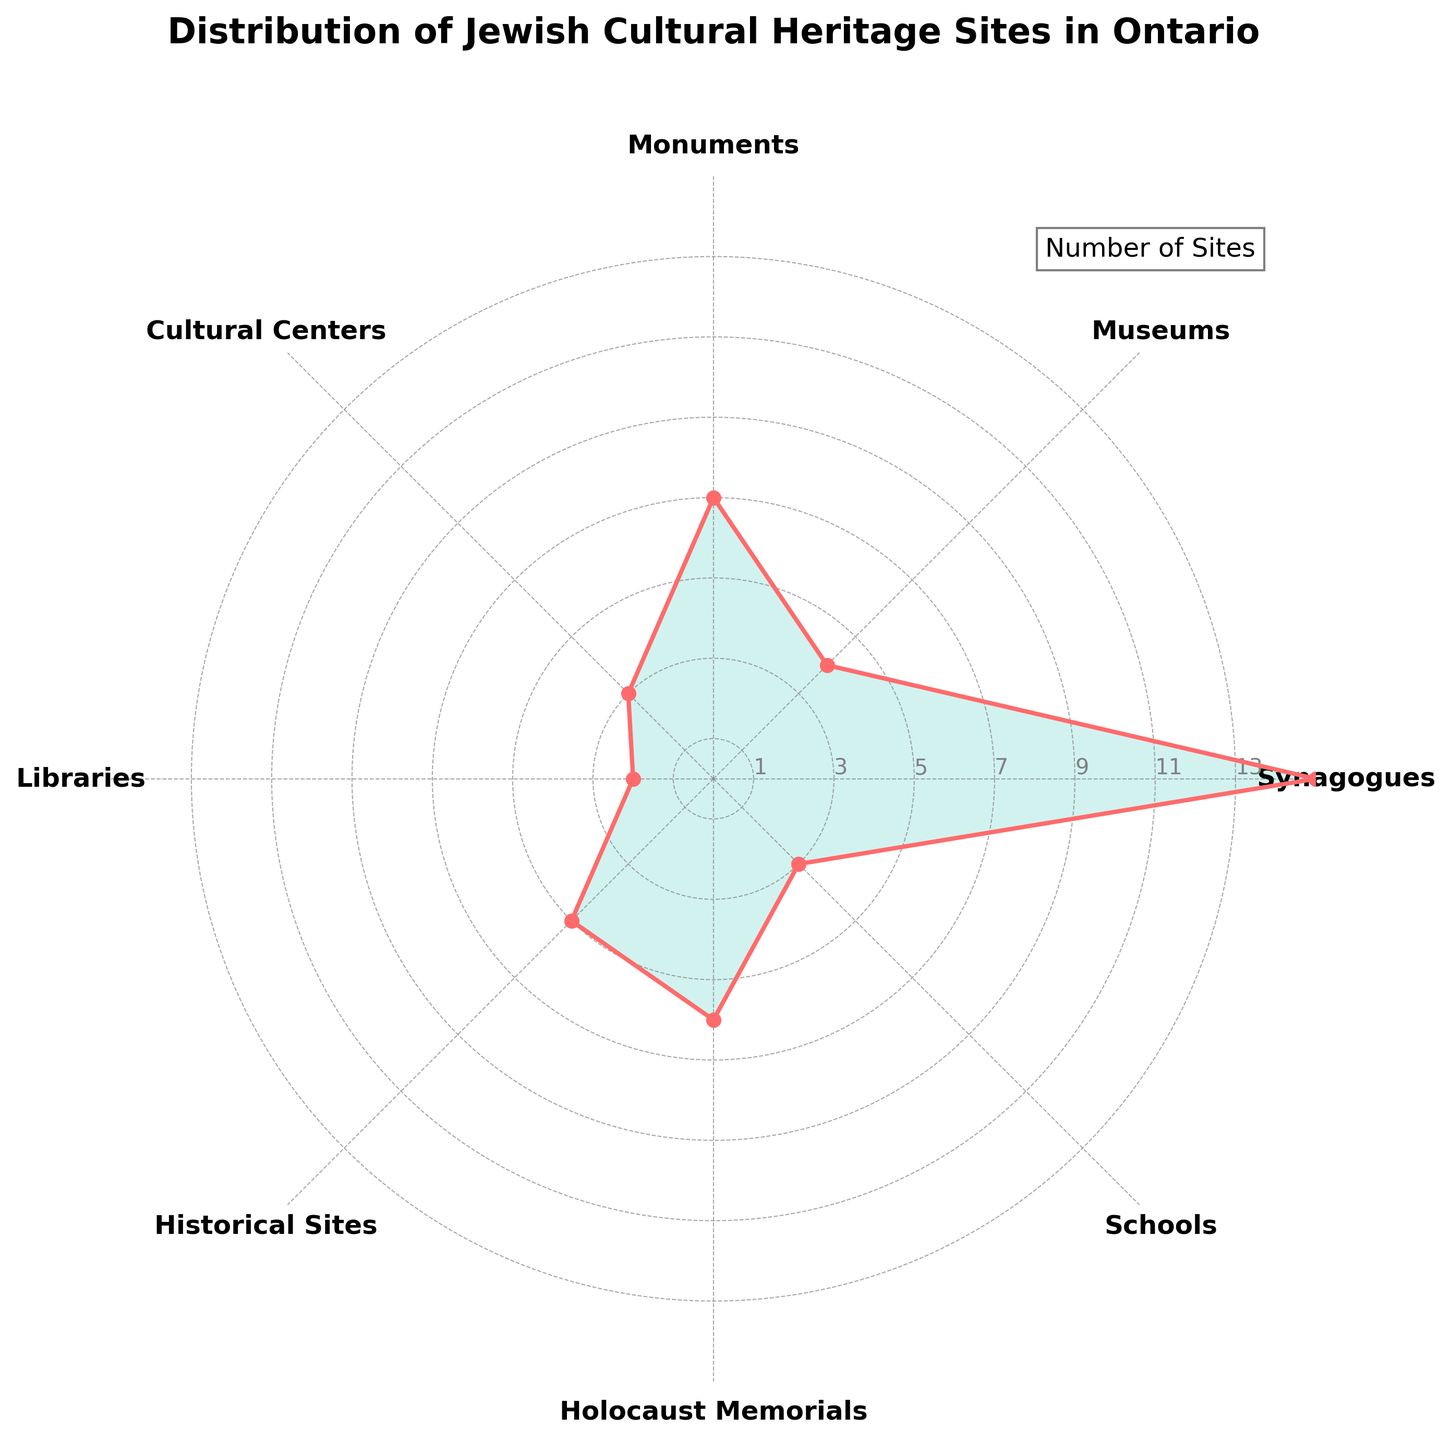What is the title of the polar chart? The title of the polar chart is written at the top and gives an overall description of the figure.
Answer: Distribution of Jewish Cultural Heritage Sites in Ontario How many synagogues are represented in the chart? The number of synagogues can be read directly from the corresponding label and the plot point on the chart.
Answer: 15 Which type of site has the second highest count? By looking at the values represented for each category, the type with the second highest count is immediately below the highest one.
Answer: Monuments What is the sum of historical sites and libraries? The chart shows 5 historical sites and 2 libraries. Summing these two values: 5 + 2 = 7
Answer: 7 Which site category has fewer counts than Holocaust memorials but more than cultural centers? Locate the values for Holocaust memorials (6) and cultural centers (3), and identify the category with a value between these two.
Answer: Historical Sites How many different types of sites are represented in the chart? Count the number of distinct labels around the polar chart.
Answer: 8 Compare the number of synagogues to the total number of schools and museums combined. Which is greater? The chart shows 15 synagogues, while the combined total for schools (3) and museums (4) is: 3 + 4 = 7. So, synagogues are greater.
Answer: Synagogues What is the difference in the number of sites between the highest and lowest categories? Synagogues are at the highest (15) and libraries at the lowest (2). Subtracting these gives: 15 - 2 = 13
Answer: 13 Are there any categories with equal number of sites? If so, which ones? By comparing the values for each category, identify any that have the same count.
Answer: Cultural Centers and Schools both have 3 How many categories have more than 5 sites? Count all categories where the values exceed 5 as shown on the chart.
Answer: 3 